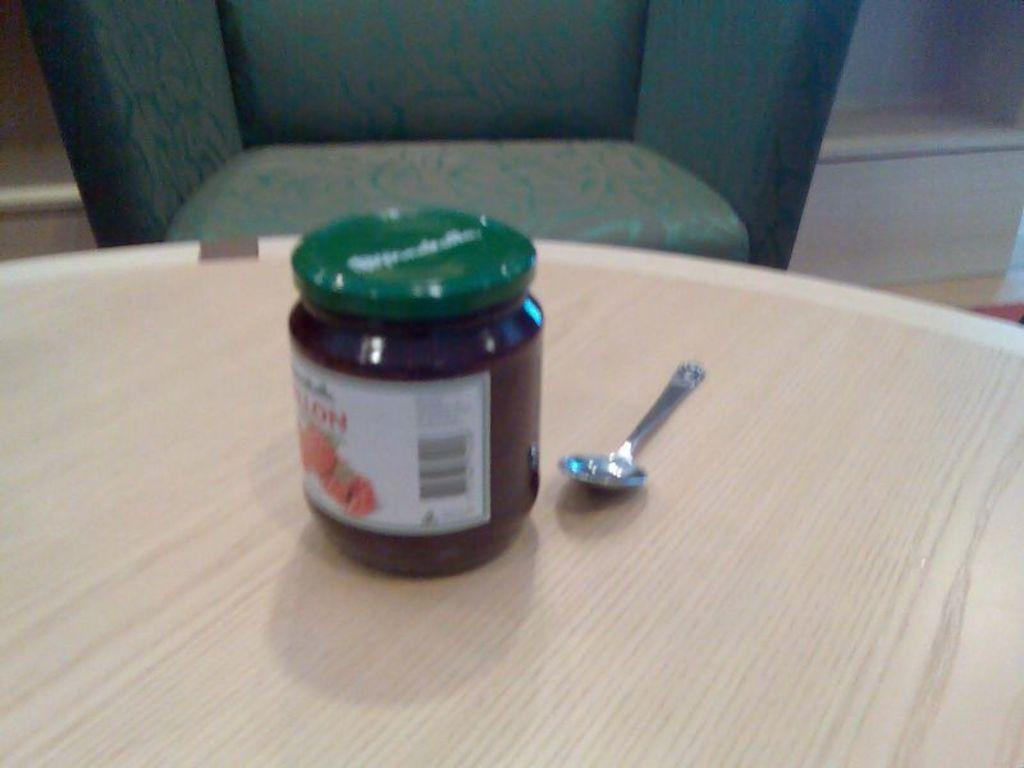What type of furniture is present in the image? There is a table and a chair in the image. What is placed on the chair? There is a bottle and a spoon on the chair. Can you describe the zephyr blowing across the lake in the image? There is no zephyr or lake present in the image; it only features a table, a chair, a bottle, and a spoon. 